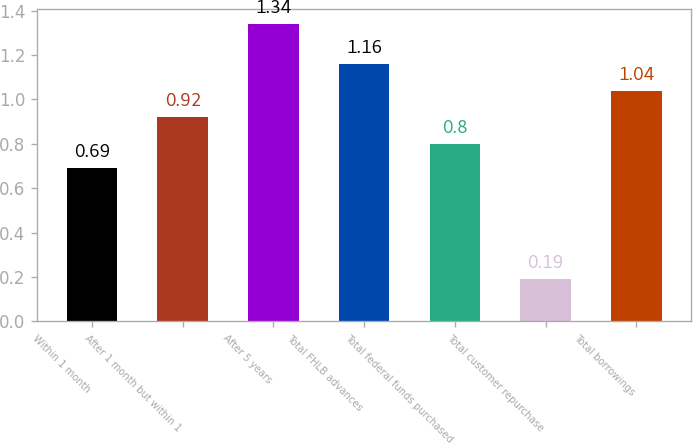Convert chart. <chart><loc_0><loc_0><loc_500><loc_500><bar_chart><fcel>Within 1 month<fcel>After 1 month but within 1<fcel>After 5 years<fcel>Total FHLB advances<fcel>Total federal funds purchased<fcel>Total customer repurchase<fcel>Total borrowings<nl><fcel>0.69<fcel>0.92<fcel>1.34<fcel>1.16<fcel>0.8<fcel>0.19<fcel>1.04<nl></chart> 